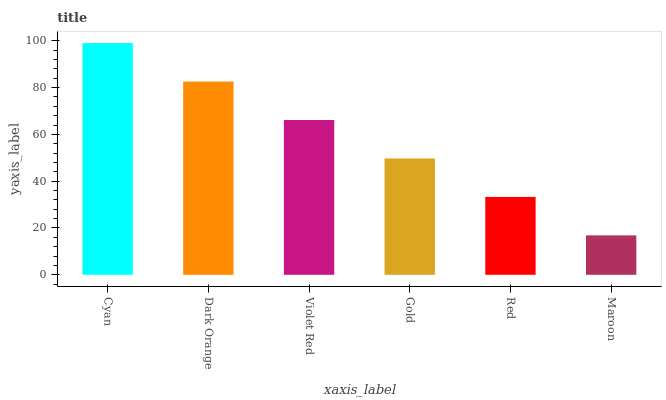Is Maroon the minimum?
Answer yes or no. Yes. Is Cyan the maximum?
Answer yes or no. Yes. Is Dark Orange the minimum?
Answer yes or no. No. Is Dark Orange the maximum?
Answer yes or no. No. Is Cyan greater than Dark Orange?
Answer yes or no. Yes. Is Dark Orange less than Cyan?
Answer yes or no. Yes. Is Dark Orange greater than Cyan?
Answer yes or no. No. Is Cyan less than Dark Orange?
Answer yes or no. No. Is Violet Red the high median?
Answer yes or no. Yes. Is Gold the low median?
Answer yes or no. Yes. Is Maroon the high median?
Answer yes or no. No. Is Red the low median?
Answer yes or no. No. 